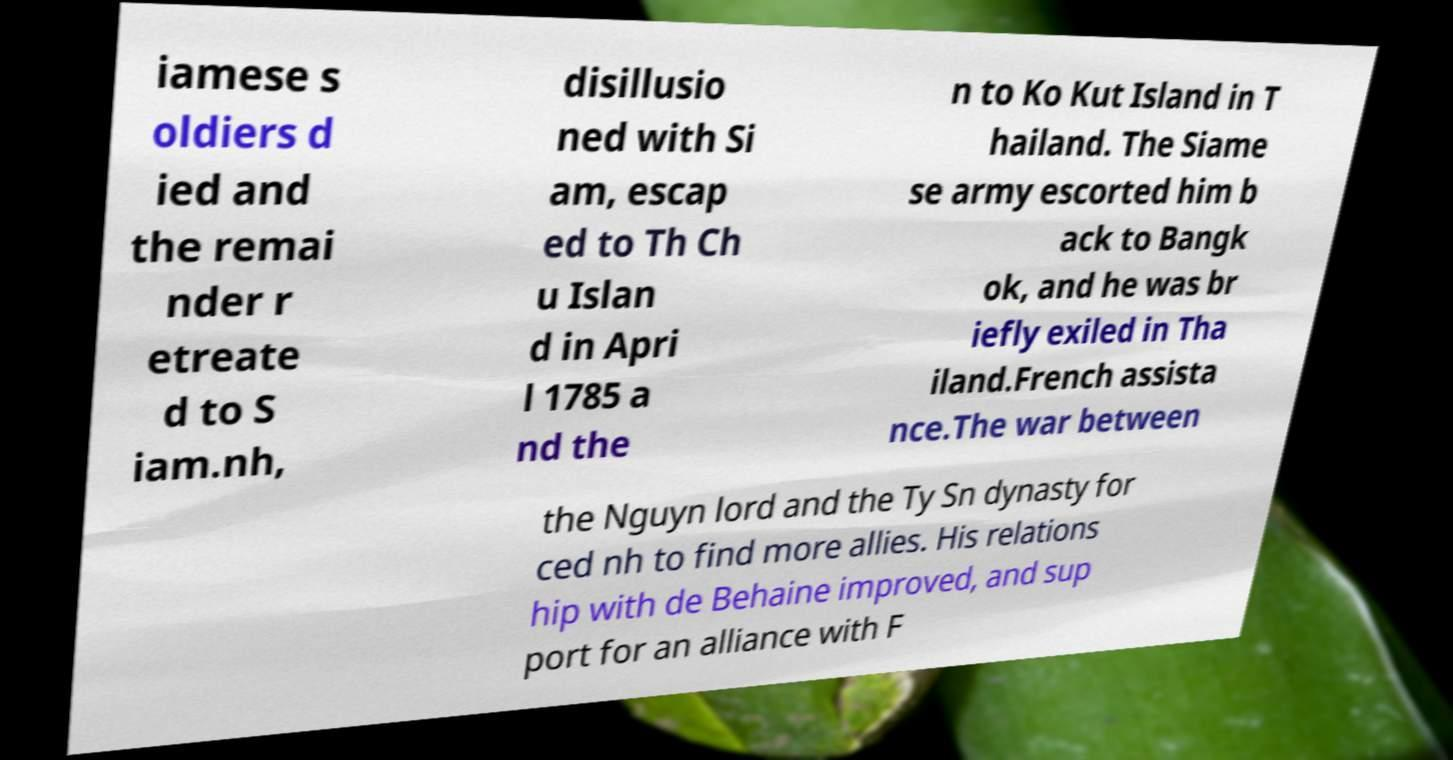There's text embedded in this image that I need extracted. Can you transcribe it verbatim? iamese s oldiers d ied and the remai nder r etreate d to S iam.nh, disillusio ned with Si am, escap ed to Th Ch u Islan d in Apri l 1785 a nd the n to Ko Kut Island in T hailand. The Siame se army escorted him b ack to Bangk ok, and he was br iefly exiled in Tha iland.French assista nce.The war between the Nguyn lord and the Ty Sn dynasty for ced nh to find more allies. His relations hip with de Behaine improved, and sup port for an alliance with F 